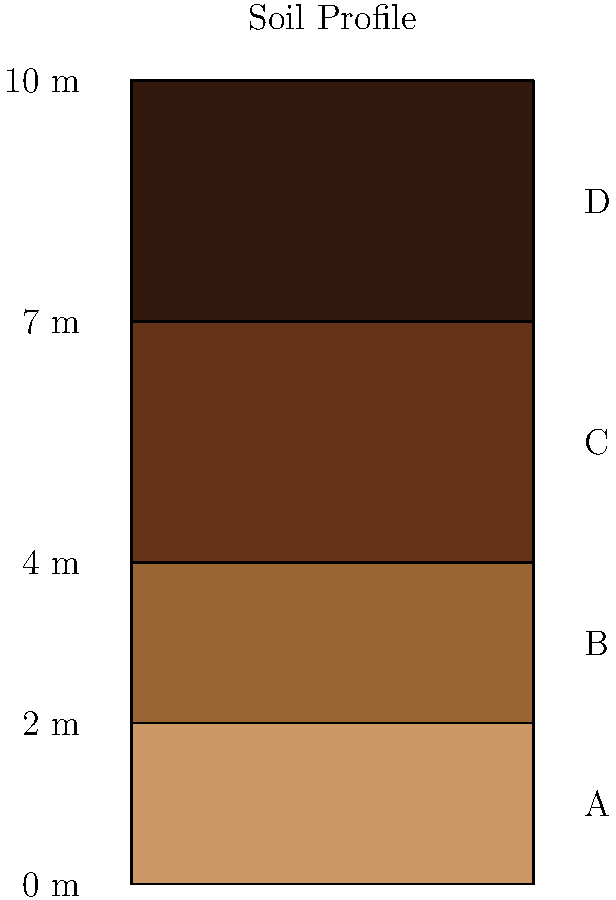In the given soil profile diagram, identify the layer that is most likely to be composed of dense, compacted soil with high bearing capacity. Explain your reasoning based on the characteristics of soil layers in a typical profile. To identify the layer with dense, compacted soil and high bearing capacity, we need to consider the typical arrangement of soil layers in a profile:

1. Layer A (0-2m): This is typically the topsoil or surface layer. It's usually loose, organic-rich, and not suitable for bearing heavy loads.

2. Layer B (2-4m): This is often a transition layer between topsoil and subsoil. It may have some compaction but is not typically the densest layer.

3. Layer C (4-7m): This layer is likely to be the subsoil. In many soil profiles, the subsoil is denser and more compacted than the layers above it. It often has the following characteristics:
   - Higher clay content
   - More compacted due to the weight of overlying layers
   - Less affected by surface processes like weathering and organic matter accumulation
   - Generally has higher bearing capacity

4. Layer D (7-10m): This deepest layer could be bedrock or a very dense soil layer. While it might have high bearing capacity, it's often too deep for practical foundation purposes without special engineering considerations.

Given these typical characteristics, Layer C (4-7m) is most likely to be composed of dense, compacted soil with high bearing capacity. It's deep enough to be well-compacted by overlying layers but not so deep as to be impractical for many foundation applications.
Answer: Layer C (4-7m) 